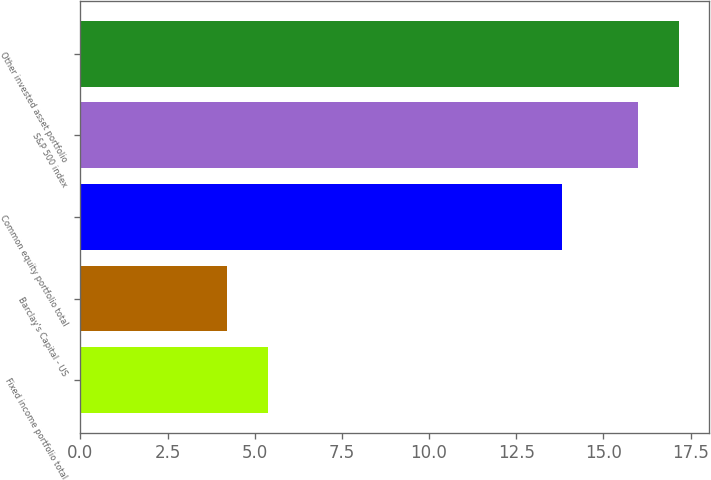Convert chart to OTSL. <chart><loc_0><loc_0><loc_500><loc_500><bar_chart><fcel>Fixed income portfolio total<fcel>Barclay's Capital - US<fcel>Common equity portfolio total<fcel>S&P 500 index<fcel>Other invested asset portfolio<nl><fcel>5.38<fcel>4.2<fcel>13.8<fcel>16<fcel>17.18<nl></chart> 